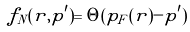<formula> <loc_0><loc_0><loc_500><loc_500>f _ { N } ( { r , p ^ { \prime } } ) = \Theta ( p _ { F } ( { r } ) - p ^ { \prime } )</formula> 